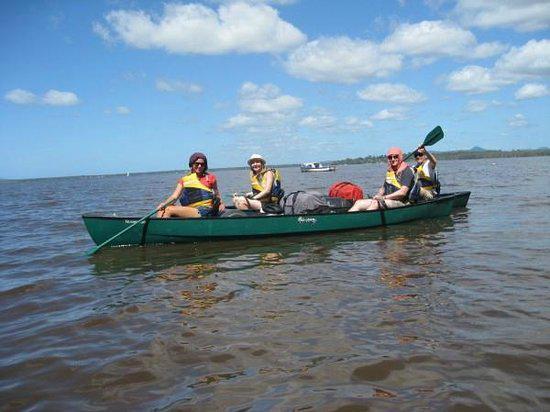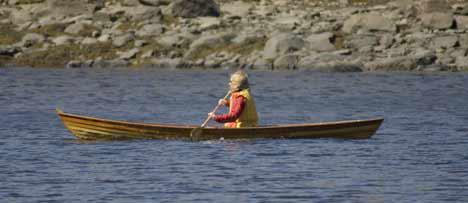The first image is the image on the left, the second image is the image on the right. Examine the images to the left and right. Is the description "The right hand image shows a flotation device with multiple red spears on the bottom and a flat plank-like object resting across the spears." accurate? Answer yes or no. No. The first image is the image on the left, the second image is the image on the right. Assess this claim about the two images: "An image shows one watercraft made of three floating red parts joined on top by a rectangular shape.". Correct or not? Answer yes or no. No. 